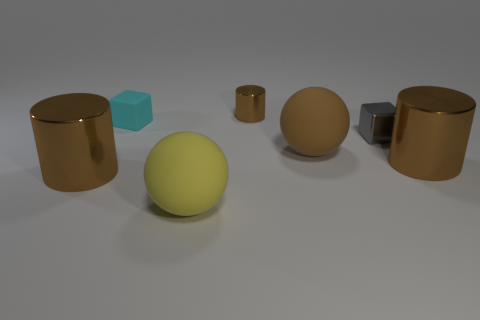Subtract all brown cylinders. How many were subtracted if there are1brown cylinders left? 2 Subtract all tiny brown metal cylinders. How many cylinders are left? 2 Add 1 small red blocks. How many objects exist? 8 Subtract all brown cylinders. How many cyan spheres are left? 0 Subtract 2 cylinders. How many cylinders are left? 1 Subtract all cyan cylinders. Subtract all brown balls. How many cylinders are left? 3 Subtract all cyan blocks. Subtract all tiny cyan matte cubes. How many objects are left? 5 Add 3 big yellow matte objects. How many big yellow matte objects are left? 4 Add 1 big shiny cylinders. How many big shiny cylinders exist? 3 Subtract 0 red cylinders. How many objects are left? 7 